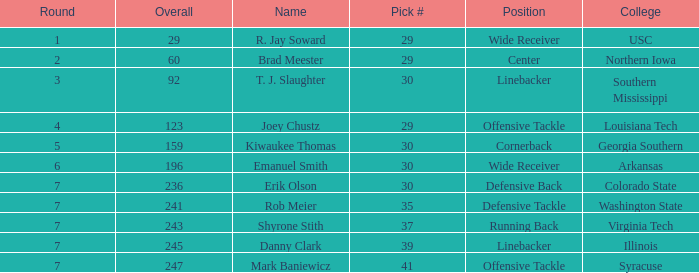What is the average Round for wide receiver r. jay soward and Overall smaller than 29? None. 